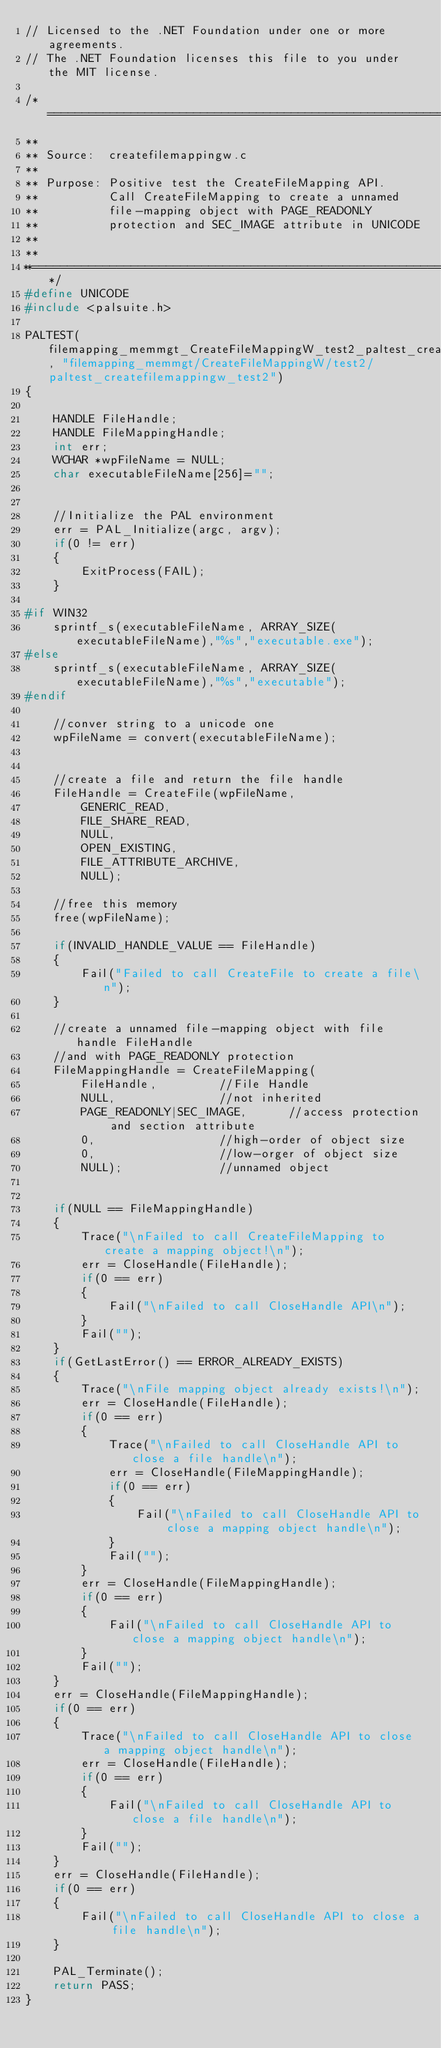<code> <loc_0><loc_0><loc_500><loc_500><_C++_>// Licensed to the .NET Foundation under one or more agreements.
// The .NET Foundation licenses this file to you under the MIT license.

/*=============================================================
**
** Source:  createfilemappingw.c
**
** Purpose: Positive test the CreateFileMapping API.
**          Call CreateFileMapping to create a unnamed
**          file-mapping object with PAGE_READONLY
**          protection and SEC_IMAGE attribute in UNICODE
**
**
**============================================================*/
#define UNICODE
#include <palsuite.h>

PALTEST(filemapping_memmgt_CreateFileMappingW_test2_paltest_createfilemappingw_test2, "filemapping_memmgt/CreateFileMappingW/test2/paltest_createfilemappingw_test2")
{

    HANDLE FileHandle;
    HANDLE FileMappingHandle;
    int err;
    WCHAR *wpFileName = NULL;
    char executableFileName[256]="";


    //Initialize the PAL environment
    err = PAL_Initialize(argc, argv);
    if(0 != err)
    {
        ExitProcess(FAIL);
    }

#if WIN32
    sprintf_s(executableFileName, ARRAY_SIZE(executableFileName),"%s","executable.exe");
#else
    sprintf_s(executableFileName, ARRAY_SIZE(executableFileName),"%s","executable");
#endif

    //conver string to a unicode one
    wpFileName = convert(executableFileName);


    //create a file and return the file handle
    FileHandle = CreateFile(wpFileName,
        GENERIC_READ,
        FILE_SHARE_READ,
        NULL,
        OPEN_EXISTING,
        FILE_ATTRIBUTE_ARCHIVE,
        NULL);

    //free this memory
    free(wpFileName);

    if(INVALID_HANDLE_VALUE == FileHandle)
    {
        Fail("Failed to call CreateFile to create a file\n");
    }

    //create a unnamed file-mapping object with file handle FileHandle
    //and with PAGE_READONLY protection
    FileMappingHandle = CreateFileMapping(
        FileHandle,         //File Handle
        NULL,               //not inherited
        PAGE_READONLY|SEC_IMAGE,      //access protection and section attribute
        0,                  //high-order of object size
        0,                  //low-orger of object size
        NULL);              //unnamed object


    if(NULL == FileMappingHandle)
    {
        Trace("\nFailed to call CreateFileMapping to create a mapping object!\n");
        err = CloseHandle(FileHandle);
        if(0 == err)
        {
            Fail("\nFailed to call CloseHandle API\n");
        }
        Fail("");
    }
    if(GetLastError() == ERROR_ALREADY_EXISTS)
    {
        Trace("\nFile mapping object already exists!\n");
        err = CloseHandle(FileHandle);
        if(0 == err)
        {
            Trace("\nFailed to call CloseHandle API to close a file handle\n");
            err = CloseHandle(FileMappingHandle);
            if(0 == err)
            {
                Fail("\nFailed to call CloseHandle API to close a mapping object handle\n");
            }
            Fail("");
        }
        err = CloseHandle(FileMappingHandle);
        if(0 == err)
        {
            Fail("\nFailed to call CloseHandle API to close a mapping object handle\n");
        }
        Fail("");
    }
    err = CloseHandle(FileMappingHandle);
    if(0 == err)
    {
        Trace("\nFailed to call CloseHandle API to close a mapping object handle\n");
        err = CloseHandle(FileHandle);
        if(0 == err)
        {
            Fail("\nFailed to call CloseHandle API to close a file handle\n");
        }
        Fail("");
    }
    err = CloseHandle(FileHandle);
    if(0 == err)
    {
        Fail("\nFailed to call CloseHandle API to close a file handle\n");
    }

    PAL_Terminate();
    return PASS;
}
</code> 